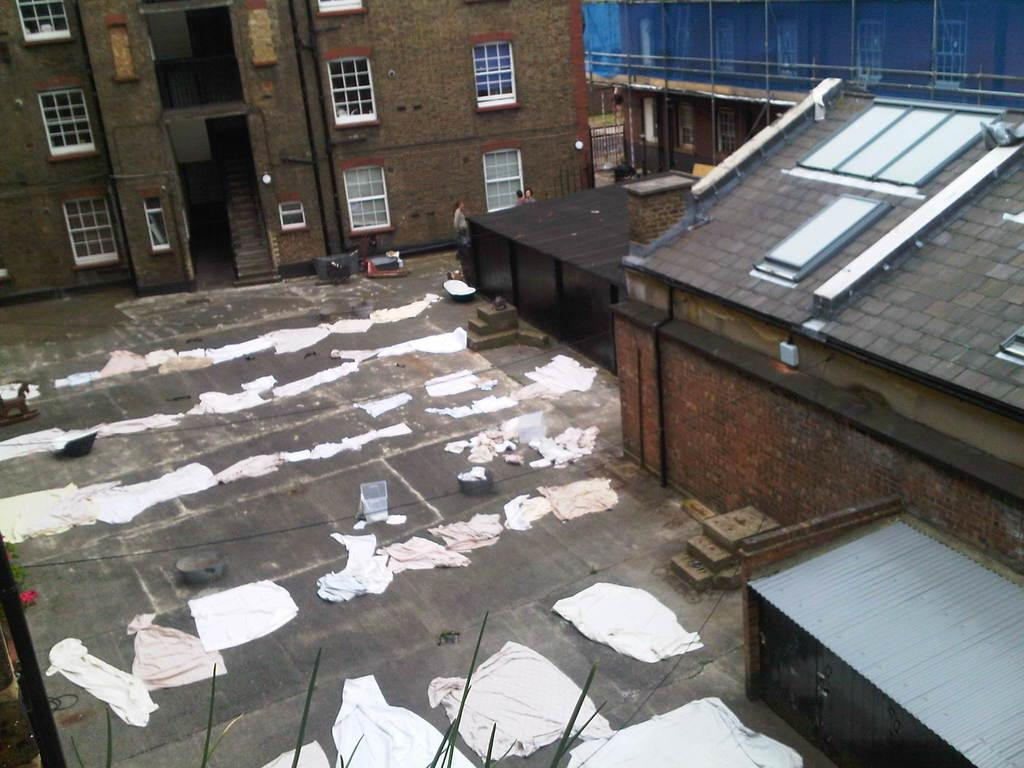What is on the ground in the image? There are clothes on the ground. What can be seen on the right side of the image? There are buildings on the right side of the image. What type of building is visible in the background of the image? There is a building with windows in the background of the image. What type of lunch is being served in the image? There is no lunch present in the image. What additional detail can be observed about the clothes on the ground? The provided facts do not mention any additional details about the clothes on the ground. 